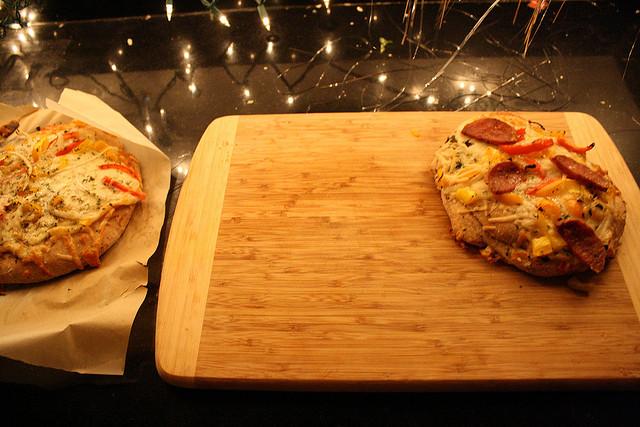What kind of lights are shining in the background of this picture?
Be succinct. Christmas lights. What type of food is being served?
Give a very brief answer. Pizza. What is the surface holding the food made of?
Answer briefly. Wood. 